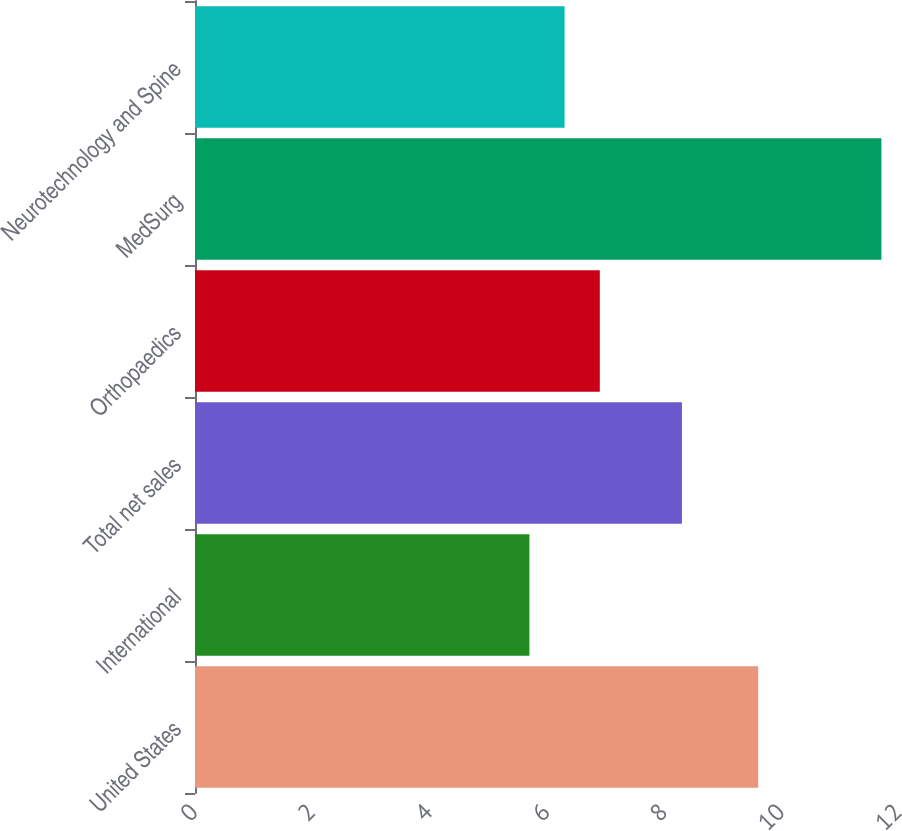<chart> <loc_0><loc_0><loc_500><loc_500><bar_chart><fcel>United States<fcel>International<fcel>Total net sales<fcel>Orthopaedics<fcel>MedSurg<fcel>Neurotechnology and Spine<nl><fcel>9.6<fcel>5.7<fcel>8.3<fcel>6.9<fcel>11.7<fcel>6.3<nl></chart> 